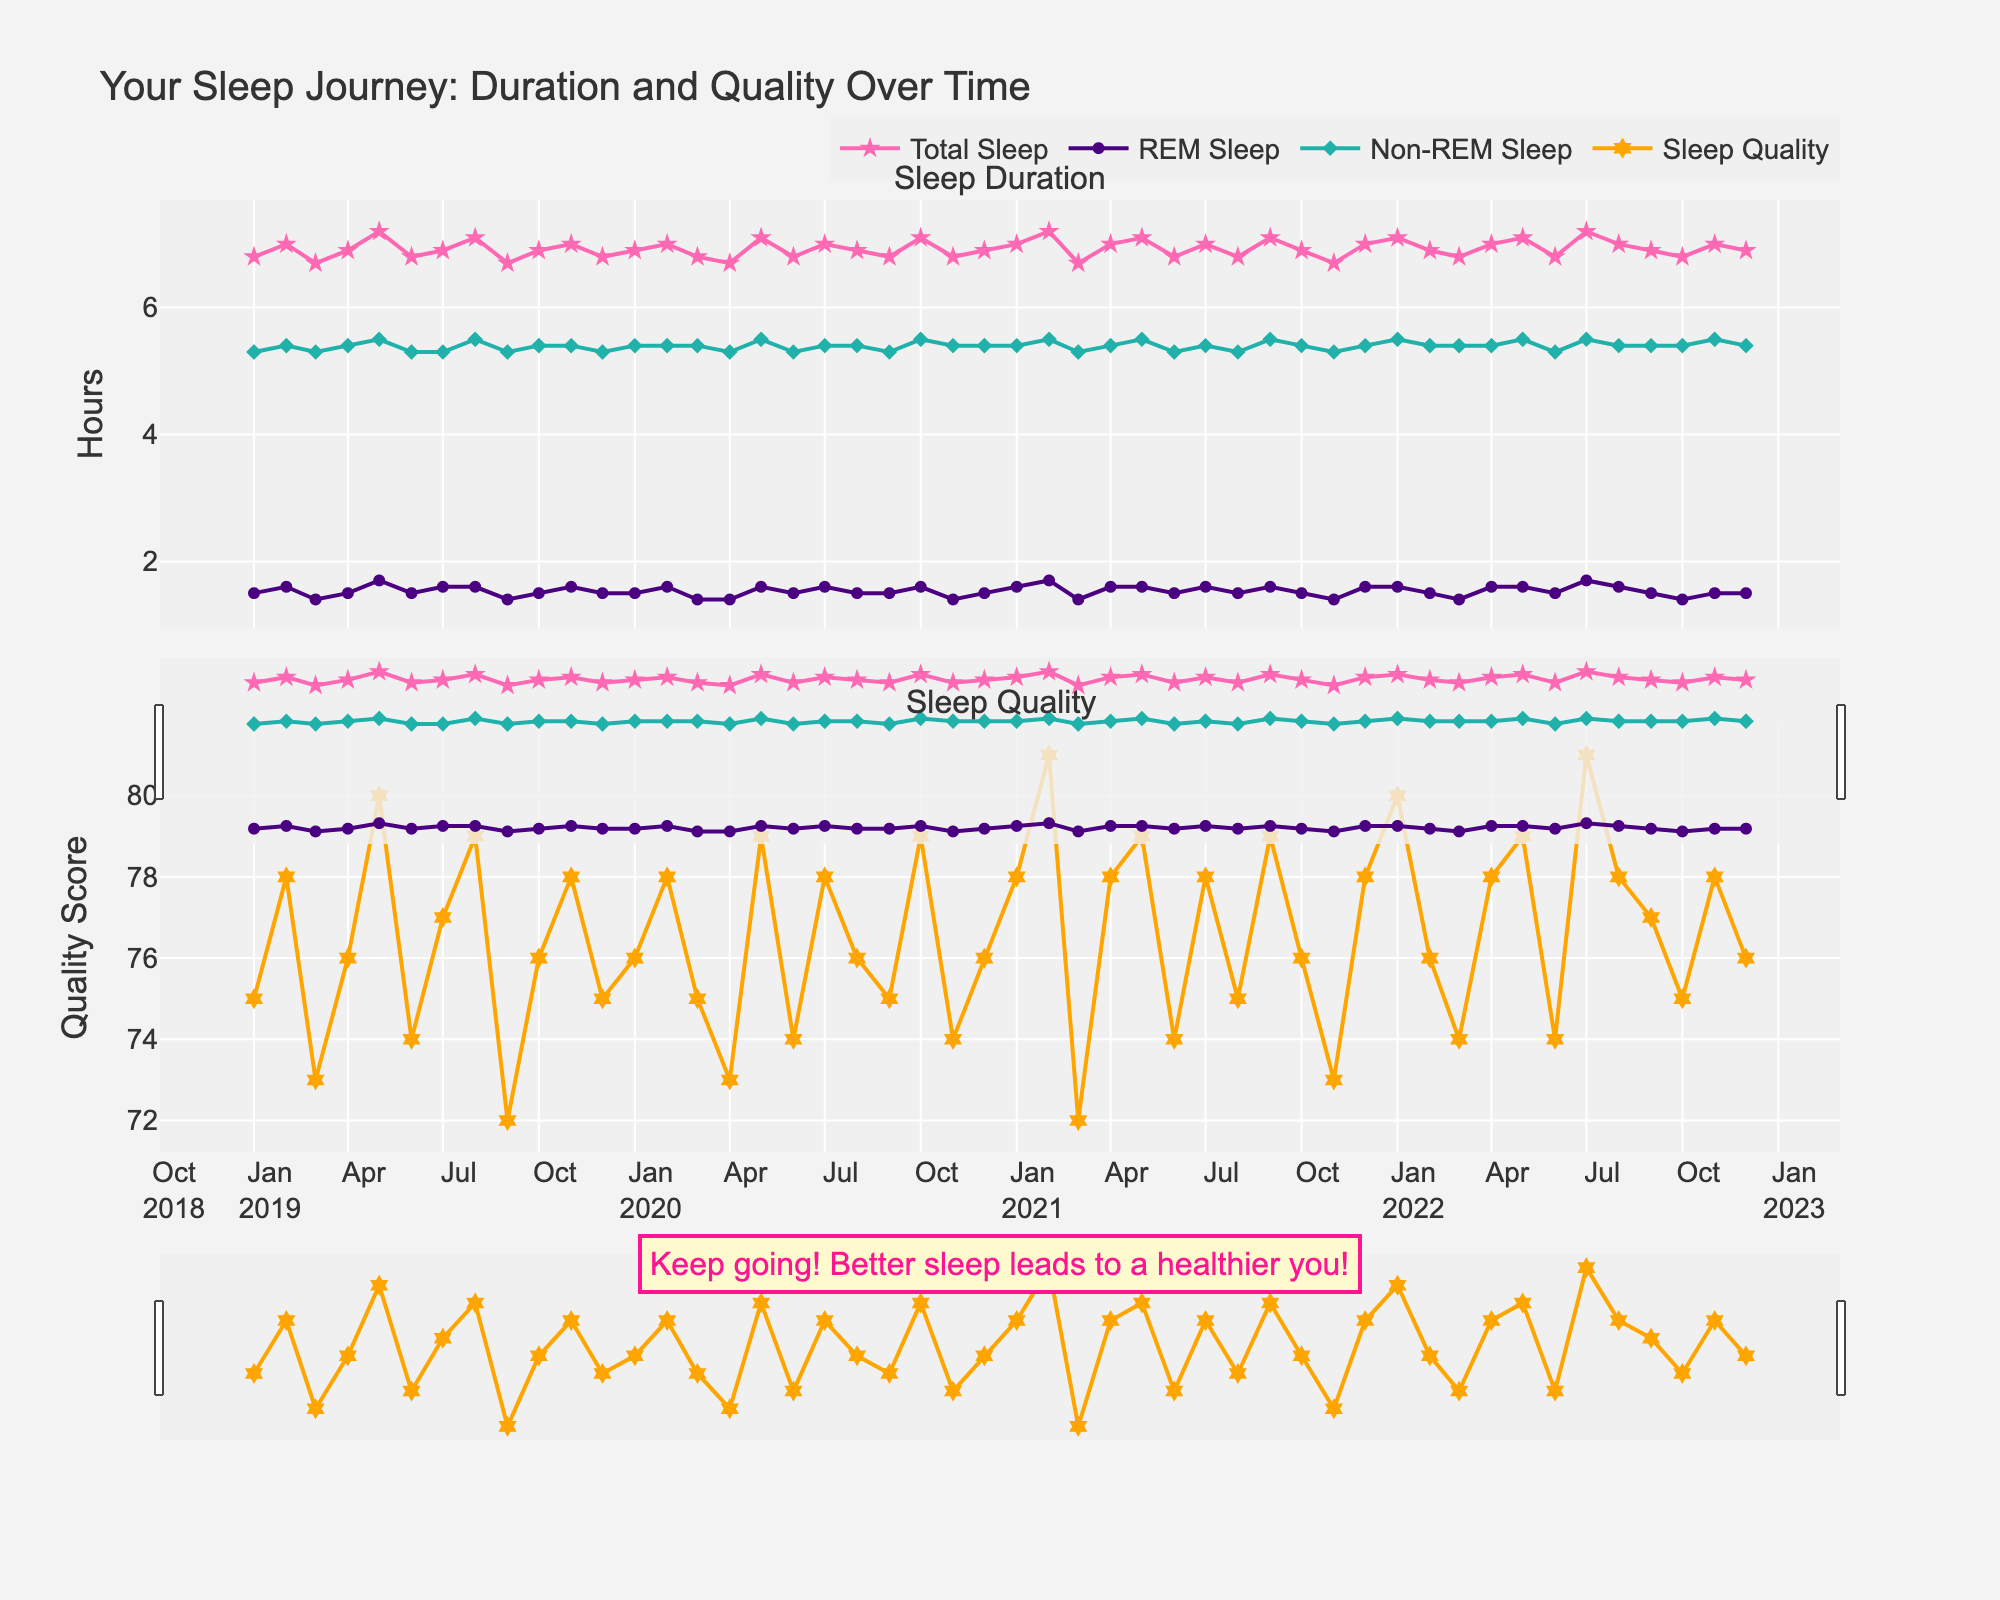What's the title of the plot? The title of the plot can be found at the top of the figure, and it provides an overview of what the plot represents.
Answer: Your Sleep Journey: Duration and Quality Over Time How many subplots are there in the figure? The figure consists of multiple plots that are stacked vertically. By observing the figure, you can see two distinct sections.
Answer: 2 What colors are used to represent the different sleep phases and quality? By looking at the different lines and markers in the plot, you can identify the colors used for each category. Total Sleep is pink, REM Sleep is purple, Non-REM Sleep is teal, and Sleep Quality is orange.
Answer: Pink, Purple, Teal, Orange What is the general trend of total sleep duration over the years? By observing the pink line in the first subplot, you can see that the total sleep duration fluctuates but generally remains steady around 6.8 to 7.2 hours. This gives insight into the overall sleep patterns.
Answer: Fairly consistent How does the REM sleep duration compare to Non-REM sleep duration? By observing the REM (purple) and Non-REM (teal) lines in the first subplot, you can note that Non-REM sleep duration is consistently higher than REM sleep duration over the time frame.
Answer: Non-REM is higher What can you infer about the relationship between sleep duration and sleep quality? By comparing the trends in the two subplots, if both show an upward trend at the same points, it indicates that an increase in sleep duration may correlate with higher sleep quality scores. Generally, periods of higher sleep duration align with higher sleep quality scores.
Answer: Positive correlation Which month and year have the highest sleep quality score? By examining the peaks in the orange line in the second subplot, you can identify the month and year with the highest value. This occurs in July 2021, where the score reaches 81.
Answer: July 2021 What’s the average sleep quality score over the entire period? To get the average sleep quality score, sum all the sleep quality scores and divide by the number of data points. (75 + 78 + 73 + 76 + 80 + 74 + 77 + 79 + 72 + 76 + 78 + 75 + 76 + 78 + 75 + 73 + 79 + 74 + 78 + 76 + 75 + 79 + 74 + 76 + 78 + 81 + 72 + 78 + 79 + 74 + 78 + 75 + 79 + 76 + 73 + 78 + 80 + 76 + 74 + 78 + 79 + 74 + 81 + 78 + 77 + 75 + 78 + 76)/48 = 76.40625
Answer: 76.4 Did the total sleep duration, REM sleep, and Non-REM sleep show any noticeable decrease or increase in specific months or years? By examining the first subplot, you can identify any periods where the sleep metrics show noticeable changes. The most notable increments are in May and July across the years, whereas slight declines appear in March and September consistently.
Answer: May and July increase, March and September decrease 